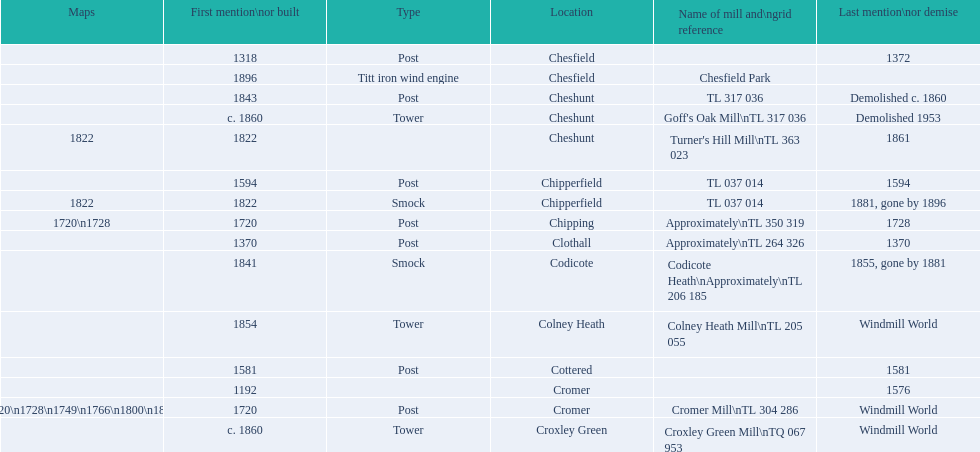How many mills were built or first mentioned after 1800? 8. 